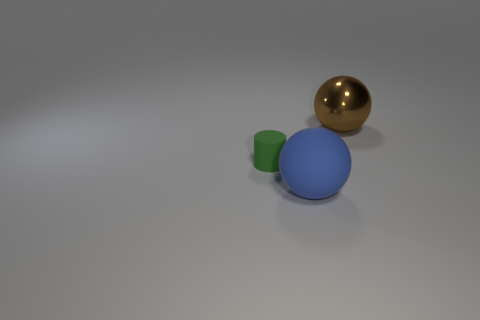Add 1 rubber cylinders. How many objects exist? 4 Subtract 1 balls. How many balls are left? 1 Subtract all cylinders. How many objects are left? 2 Subtract 1 blue balls. How many objects are left? 2 Subtract all blue balls. Subtract all yellow cylinders. How many balls are left? 1 Subtract all cyan balls. How many red cylinders are left? 0 Subtract all blue rubber cubes. Subtract all large blue matte balls. How many objects are left? 2 Add 1 blue matte spheres. How many blue matte spheres are left? 2 Add 3 tiny matte spheres. How many tiny matte spheres exist? 3 